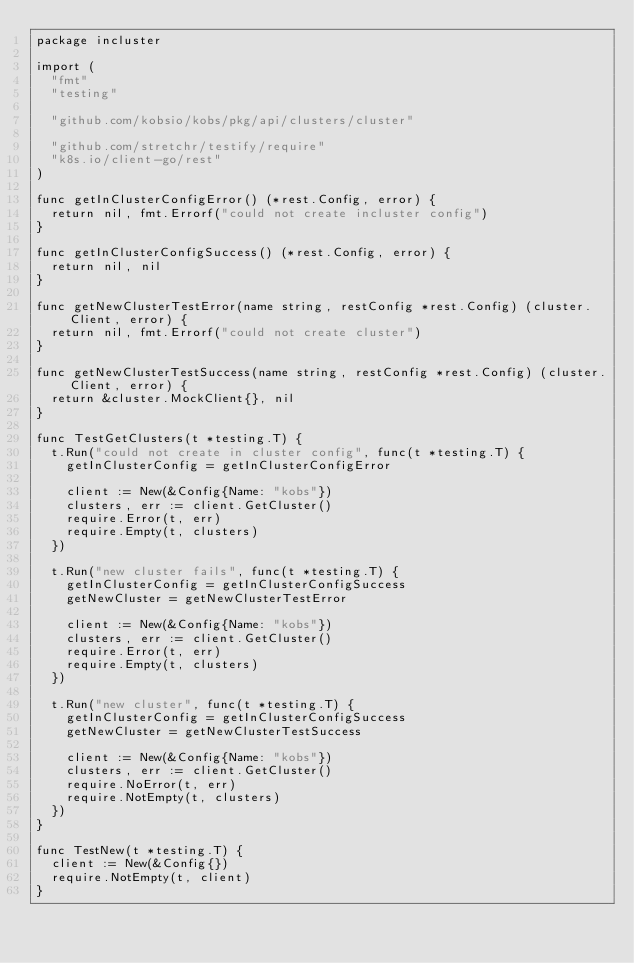Convert code to text. <code><loc_0><loc_0><loc_500><loc_500><_Go_>package incluster

import (
	"fmt"
	"testing"

	"github.com/kobsio/kobs/pkg/api/clusters/cluster"

	"github.com/stretchr/testify/require"
	"k8s.io/client-go/rest"
)

func getInClusterConfigError() (*rest.Config, error) {
	return nil, fmt.Errorf("could not create incluster config")
}

func getInClusterConfigSuccess() (*rest.Config, error) {
	return nil, nil
}

func getNewClusterTestError(name string, restConfig *rest.Config) (cluster.Client, error) {
	return nil, fmt.Errorf("could not create cluster")
}

func getNewClusterTestSuccess(name string, restConfig *rest.Config) (cluster.Client, error) {
	return &cluster.MockClient{}, nil
}

func TestGetClusters(t *testing.T) {
	t.Run("could not create in cluster config", func(t *testing.T) {
		getInClusterConfig = getInClusterConfigError

		client := New(&Config{Name: "kobs"})
		clusters, err := client.GetCluster()
		require.Error(t, err)
		require.Empty(t, clusters)
	})

	t.Run("new cluster fails", func(t *testing.T) {
		getInClusterConfig = getInClusterConfigSuccess
		getNewCluster = getNewClusterTestError

		client := New(&Config{Name: "kobs"})
		clusters, err := client.GetCluster()
		require.Error(t, err)
		require.Empty(t, clusters)
	})

	t.Run("new cluster", func(t *testing.T) {
		getInClusterConfig = getInClusterConfigSuccess
		getNewCluster = getNewClusterTestSuccess

		client := New(&Config{Name: "kobs"})
		clusters, err := client.GetCluster()
		require.NoError(t, err)
		require.NotEmpty(t, clusters)
	})
}

func TestNew(t *testing.T) {
	client := New(&Config{})
	require.NotEmpty(t, client)
}
</code> 